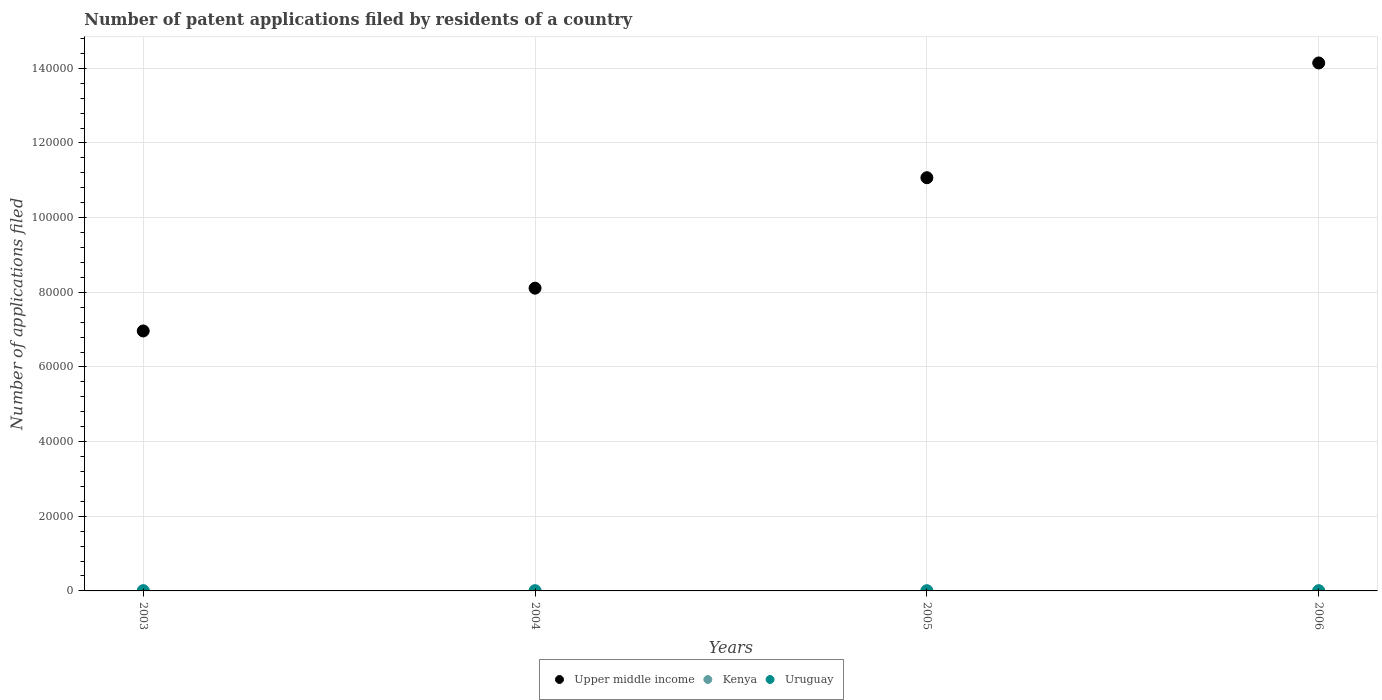Is the number of dotlines equal to the number of legend labels?
Your answer should be very brief. Yes. What is the number of applications filed in Upper middle income in 2004?
Provide a short and direct response. 8.11e+04. Across all years, what is the minimum number of applications filed in Upper middle income?
Provide a succinct answer. 6.96e+04. What is the total number of applications filed in Kenya in the graph?
Keep it short and to the point. 128. What is the difference between the number of applications filed in Upper middle income in 2003 and that in 2006?
Provide a succinct answer. -7.18e+04. What is the difference between the number of applications filed in Upper middle income in 2003 and the number of applications filed in Kenya in 2005?
Ensure brevity in your answer.  6.96e+04. What is the average number of applications filed in Uruguay per year?
Ensure brevity in your answer.  34.25. In the year 2005, what is the difference between the number of applications filed in Kenya and number of applications filed in Uruguay?
Ensure brevity in your answer.  10. In how many years, is the number of applications filed in Kenya greater than 128000?
Your response must be concise. 0. What is the ratio of the number of applications filed in Uruguay in 2005 to that in 2006?
Your answer should be compact. 0.77. Is the difference between the number of applications filed in Kenya in 2003 and 2005 greater than the difference between the number of applications filed in Uruguay in 2003 and 2005?
Your response must be concise. No. What is the difference between the highest and the second highest number of applications filed in Upper middle income?
Your answer should be very brief. 3.07e+04. What is the difference between the highest and the lowest number of applications filed in Uruguay?
Make the answer very short. 21. Is the sum of the number of applications filed in Upper middle income in 2004 and 2006 greater than the maximum number of applications filed in Uruguay across all years?
Offer a very short reply. Yes. Is it the case that in every year, the sum of the number of applications filed in Upper middle income and number of applications filed in Uruguay  is greater than the number of applications filed in Kenya?
Your response must be concise. Yes. Is the number of applications filed in Kenya strictly greater than the number of applications filed in Upper middle income over the years?
Your response must be concise. No. Are the values on the major ticks of Y-axis written in scientific E-notation?
Ensure brevity in your answer.  No. Does the graph contain any zero values?
Keep it short and to the point. No. What is the title of the graph?
Keep it short and to the point. Number of patent applications filed by residents of a country. Does "St. Vincent and the Grenadines" appear as one of the legend labels in the graph?
Offer a very short reply. No. What is the label or title of the X-axis?
Make the answer very short. Years. What is the label or title of the Y-axis?
Ensure brevity in your answer.  Number of applications filed. What is the Number of applications filed in Upper middle income in 2003?
Ensure brevity in your answer.  6.96e+04. What is the Number of applications filed in Kenya in 2003?
Your answer should be compact. 22. What is the Number of applications filed in Upper middle income in 2004?
Offer a very short reply. 8.11e+04. What is the Number of applications filed of Kenya in 2004?
Your answer should be very brief. 31. What is the Number of applications filed in Uruguay in 2004?
Offer a terse response. 37. What is the Number of applications filed of Upper middle income in 2005?
Make the answer very short. 1.11e+05. What is the Number of applications filed of Kenya in 2005?
Provide a succinct answer. 34. What is the Number of applications filed in Uruguay in 2005?
Offer a terse response. 24. What is the Number of applications filed of Upper middle income in 2006?
Your response must be concise. 1.41e+05. What is the Number of applications filed in Uruguay in 2006?
Offer a terse response. 31. Across all years, what is the maximum Number of applications filed of Upper middle income?
Make the answer very short. 1.41e+05. Across all years, what is the maximum Number of applications filed in Kenya?
Your answer should be compact. 41. Across all years, what is the minimum Number of applications filed of Upper middle income?
Your response must be concise. 6.96e+04. What is the total Number of applications filed of Upper middle income in the graph?
Provide a short and direct response. 4.03e+05. What is the total Number of applications filed in Kenya in the graph?
Keep it short and to the point. 128. What is the total Number of applications filed of Uruguay in the graph?
Your answer should be compact. 137. What is the difference between the Number of applications filed of Upper middle income in 2003 and that in 2004?
Your answer should be compact. -1.15e+04. What is the difference between the Number of applications filed of Uruguay in 2003 and that in 2004?
Offer a very short reply. 8. What is the difference between the Number of applications filed of Upper middle income in 2003 and that in 2005?
Your response must be concise. -4.11e+04. What is the difference between the Number of applications filed in Upper middle income in 2003 and that in 2006?
Your response must be concise. -7.18e+04. What is the difference between the Number of applications filed in Kenya in 2003 and that in 2006?
Your answer should be very brief. -19. What is the difference between the Number of applications filed of Upper middle income in 2004 and that in 2005?
Keep it short and to the point. -2.96e+04. What is the difference between the Number of applications filed in Uruguay in 2004 and that in 2005?
Offer a very short reply. 13. What is the difference between the Number of applications filed in Upper middle income in 2004 and that in 2006?
Your response must be concise. -6.03e+04. What is the difference between the Number of applications filed of Upper middle income in 2005 and that in 2006?
Provide a succinct answer. -3.07e+04. What is the difference between the Number of applications filed of Kenya in 2005 and that in 2006?
Your answer should be compact. -7. What is the difference between the Number of applications filed in Upper middle income in 2003 and the Number of applications filed in Kenya in 2004?
Provide a succinct answer. 6.96e+04. What is the difference between the Number of applications filed of Upper middle income in 2003 and the Number of applications filed of Uruguay in 2004?
Make the answer very short. 6.96e+04. What is the difference between the Number of applications filed in Upper middle income in 2003 and the Number of applications filed in Kenya in 2005?
Your answer should be very brief. 6.96e+04. What is the difference between the Number of applications filed of Upper middle income in 2003 and the Number of applications filed of Uruguay in 2005?
Your answer should be compact. 6.96e+04. What is the difference between the Number of applications filed in Kenya in 2003 and the Number of applications filed in Uruguay in 2005?
Offer a very short reply. -2. What is the difference between the Number of applications filed in Upper middle income in 2003 and the Number of applications filed in Kenya in 2006?
Keep it short and to the point. 6.96e+04. What is the difference between the Number of applications filed in Upper middle income in 2003 and the Number of applications filed in Uruguay in 2006?
Your response must be concise. 6.96e+04. What is the difference between the Number of applications filed in Upper middle income in 2004 and the Number of applications filed in Kenya in 2005?
Keep it short and to the point. 8.11e+04. What is the difference between the Number of applications filed in Upper middle income in 2004 and the Number of applications filed in Uruguay in 2005?
Provide a short and direct response. 8.11e+04. What is the difference between the Number of applications filed in Kenya in 2004 and the Number of applications filed in Uruguay in 2005?
Provide a short and direct response. 7. What is the difference between the Number of applications filed in Upper middle income in 2004 and the Number of applications filed in Kenya in 2006?
Make the answer very short. 8.11e+04. What is the difference between the Number of applications filed in Upper middle income in 2004 and the Number of applications filed in Uruguay in 2006?
Give a very brief answer. 8.11e+04. What is the difference between the Number of applications filed of Upper middle income in 2005 and the Number of applications filed of Kenya in 2006?
Your response must be concise. 1.11e+05. What is the difference between the Number of applications filed in Upper middle income in 2005 and the Number of applications filed in Uruguay in 2006?
Your answer should be very brief. 1.11e+05. What is the average Number of applications filed in Upper middle income per year?
Offer a very short reply. 1.01e+05. What is the average Number of applications filed in Uruguay per year?
Provide a short and direct response. 34.25. In the year 2003, what is the difference between the Number of applications filed in Upper middle income and Number of applications filed in Kenya?
Your answer should be very brief. 6.96e+04. In the year 2003, what is the difference between the Number of applications filed in Upper middle income and Number of applications filed in Uruguay?
Offer a terse response. 6.96e+04. In the year 2004, what is the difference between the Number of applications filed of Upper middle income and Number of applications filed of Kenya?
Provide a succinct answer. 8.11e+04. In the year 2004, what is the difference between the Number of applications filed of Upper middle income and Number of applications filed of Uruguay?
Offer a very short reply. 8.11e+04. In the year 2005, what is the difference between the Number of applications filed of Upper middle income and Number of applications filed of Kenya?
Ensure brevity in your answer.  1.11e+05. In the year 2005, what is the difference between the Number of applications filed in Upper middle income and Number of applications filed in Uruguay?
Keep it short and to the point. 1.11e+05. In the year 2006, what is the difference between the Number of applications filed of Upper middle income and Number of applications filed of Kenya?
Your response must be concise. 1.41e+05. In the year 2006, what is the difference between the Number of applications filed in Upper middle income and Number of applications filed in Uruguay?
Make the answer very short. 1.41e+05. In the year 2006, what is the difference between the Number of applications filed in Kenya and Number of applications filed in Uruguay?
Your answer should be very brief. 10. What is the ratio of the Number of applications filed of Upper middle income in 2003 to that in 2004?
Your response must be concise. 0.86. What is the ratio of the Number of applications filed of Kenya in 2003 to that in 2004?
Offer a terse response. 0.71. What is the ratio of the Number of applications filed in Uruguay in 2003 to that in 2004?
Your answer should be compact. 1.22. What is the ratio of the Number of applications filed in Upper middle income in 2003 to that in 2005?
Provide a succinct answer. 0.63. What is the ratio of the Number of applications filed in Kenya in 2003 to that in 2005?
Keep it short and to the point. 0.65. What is the ratio of the Number of applications filed in Uruguay in 2003 to that in 2005?
Give a very brief answer. 1.88. What is the ratio of the Number of applications filed in Upper middle income in 2003 to that in 2006?
Your answer should be compact. 0.49. What is the ratio of the Number of applications filed in Kenya in 2003 to that in 2006?
Give a very brief answer. 0.54. What is the ratio of the Number of applications filed of Uruguay in 2003 to that in 2006?
Your response must be concise. 1.45. What is the ratio of the Number of applications filed in Upper middle income in 2004 to that in 2005?
Make the answer very short. 0.73. What is the ratio of the Number of applications filed in Kenya in 2004 to that in 2005?
Offer a very short reply. 0.91. What is the ratio of the Number of applications filed of Uruguay in 2004 to that in 2005?
Offer a terse response. 1.54. What is the ratio of the Number of applications filed in Upper middle income in 2004 to that in 2006?
Your answer should be very brief. 0.57. What is the ratio of the Number of applications filed of Kenya in 2004 to that in 2006?
Keep it short and to the point. 0.76. What is the ratio of the Number of applications filed of Uruguay in 2004 to that in 2006?
Make the answer very short. 1.19. What is the ratio of the Number of applications filed of Upper middle income in 2005 to that in 2006?
Your response must be concise. 0.78. What is the ratio of the Number of applications filed of Kenya in 2005 to that in 2006?
Provide a succinct answer. 0.83. What is the ratio of the Number of applications filed of Uruguay in 2005 to that in 2006?
Provide a short and direct response. 0.77. What is the difference between the highest and the second highest Number of applications filed of Upper middle income?
Your answer should be compact. 3.07e+04. What is the difference between the highest and the second highest Number of applications filed of Kenya?
Make the answer very short. 7. What is the difference between the highest and the second highest Number of applications filed of Uruguay?
Provide a short and direct response. 8. What is the difference between the highest and the lowest Number of applications filed of Upper middle income?
Provide a short and direct response. 7.18e+04. What is the difference between the highest and the lowest Number of applications filed of Kenya?
Give a very brief answer. 19. What is the difference between the highest and the lowest Number of applications filed in Uruguay?
Your response must be concise. 21. 